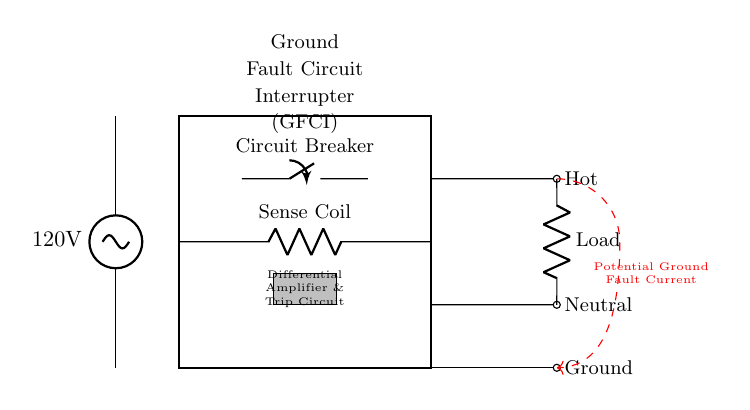What is the voltage supply in this circuit? The voltage supply is indicated in the circuit as 120 volts, which is typically the voltage used in household electrical circuits in the United States.
Answer: 120 volts What component interrupts the circuit during a ground fault? The component responsible for interrupting the circuit is the Ground Fault Circuit Interrupter (GFCI), which senses ground faults and trips to prevent electrical shock.
Answer: Ground Fault Circuit Interrupter (GFCI) How many outputs does the GFCI have? The GFCI has three outputs: one hot, one neutral, and one ground. The diagram shows the outputs connected to respective points after the GFCI device.
Answer: Three What is the purpose of the sense coil in this circuit? The sense coil monitors the current flow in the circuit to detect any imbalance, which indicates a ground fault, prompting the GFCI to trip and cut off power.
Answer: Monitor current What is the function of the circuit breaker in this design? The circuit breaker serves as a protective switch that can be opened or closed; if a fault is detected, the GFCI will trip, actuating the circuit breaker to cut power.
Answer: Protective switch What type of load is represented in this circuit? The load in this circuit is represented by a resistor, which symbolizes electrical devices that draw power from the circuit.
Answer: Resistor What color indicates a potential ground fault current in the diagram? The color red is used in the dashed line to indicate the path of the potential ground fault current, helping to visualize unsafe conditions.
Answer: Red 